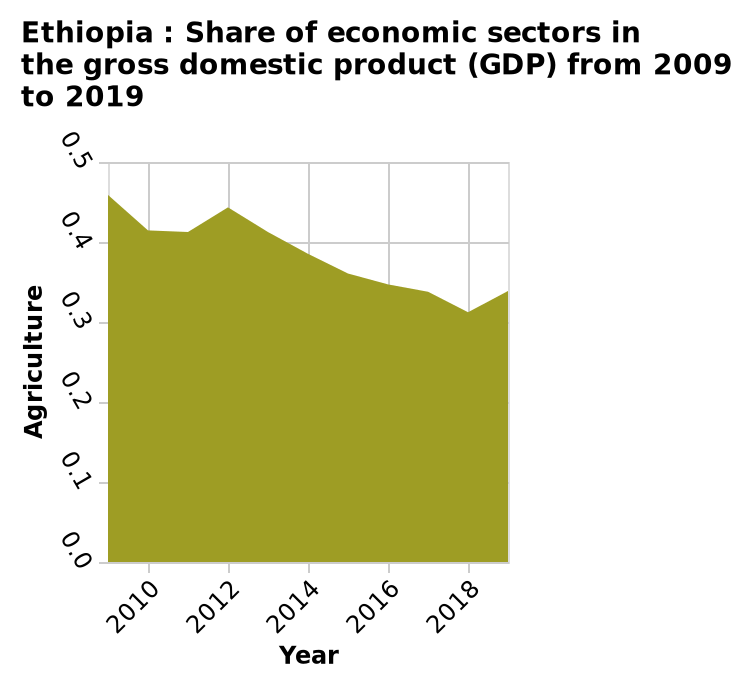<image>
When was the lowest peak in agriculture recorded in Africa?  The lowest peak in agriculture was recorded in Africa in 2018. What is the significance of the y-axis mark "Agriculture"? The y-axis mark "Agriculture" represents the share of the agriculture sector in the GDP of Ethiopia, ranging from 0.0 to 0.5. What is the range of the y-axis? The y-axis has a range from 0.0 to 0.5, representing the share of Agriculture in the gross domestic product (GDP). Does the y-axis represent the share of Agriculture in the GDP? No.The y-axis has a range from 0.0 to 0.5, representing the share of Agriculture in the gross domestic product (GDP). 